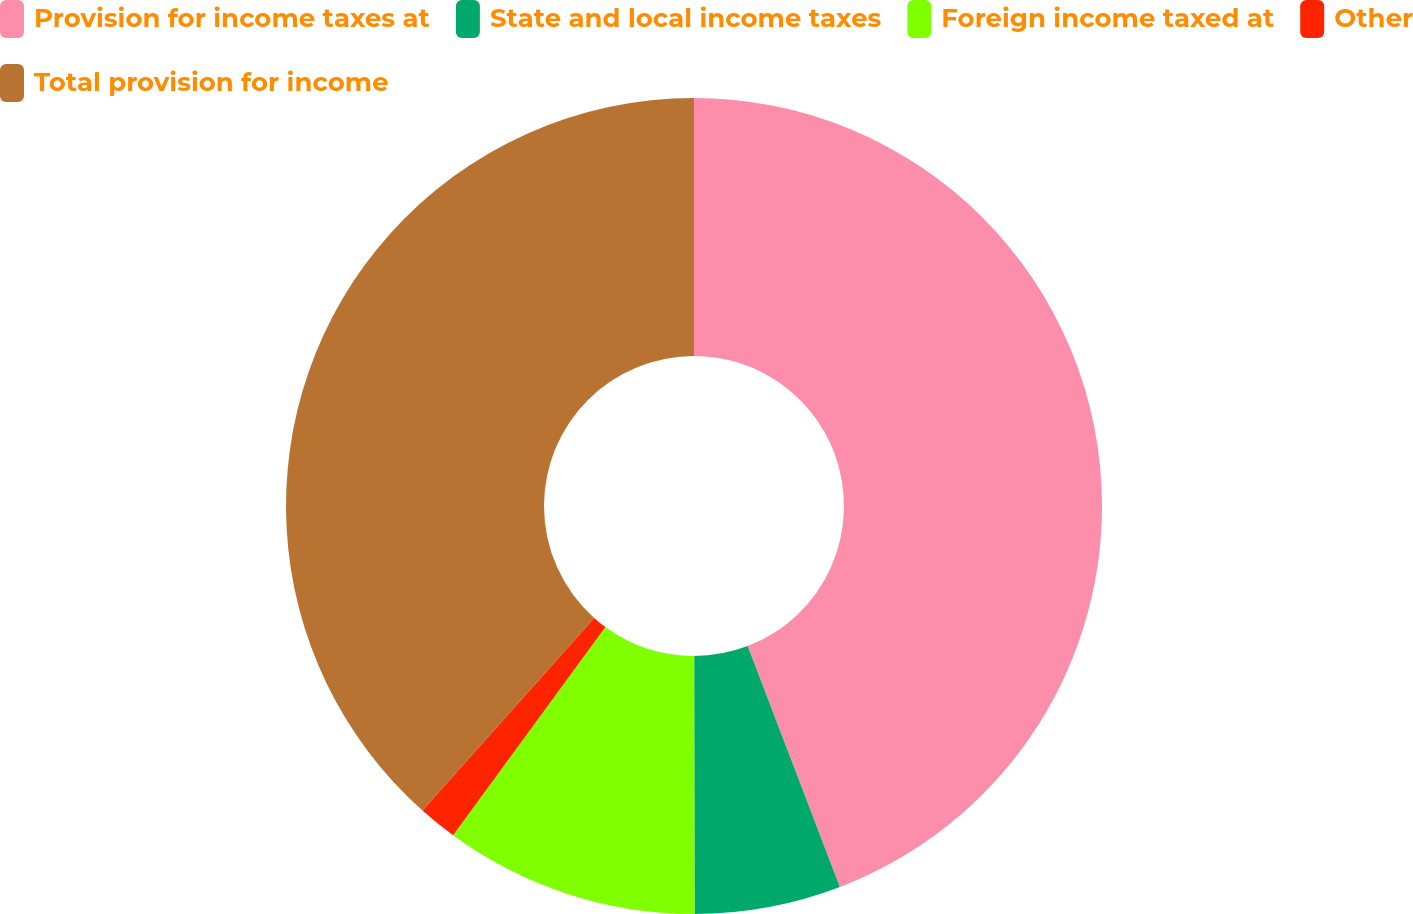Convert chart. <chart><loc_0><loc_0><loc_500><loc_500><pie_chart><fcel>Provision for income taxes at<fcel>State and local income taxes<fcel>Foreign income taxed at<fcel>Other<fcel>Total provision for income<nl><fcel>44.18%<fcel>5.8%<fcel>10.07%<fcel>1.54%<fcel>38.41%<nl></chart> 